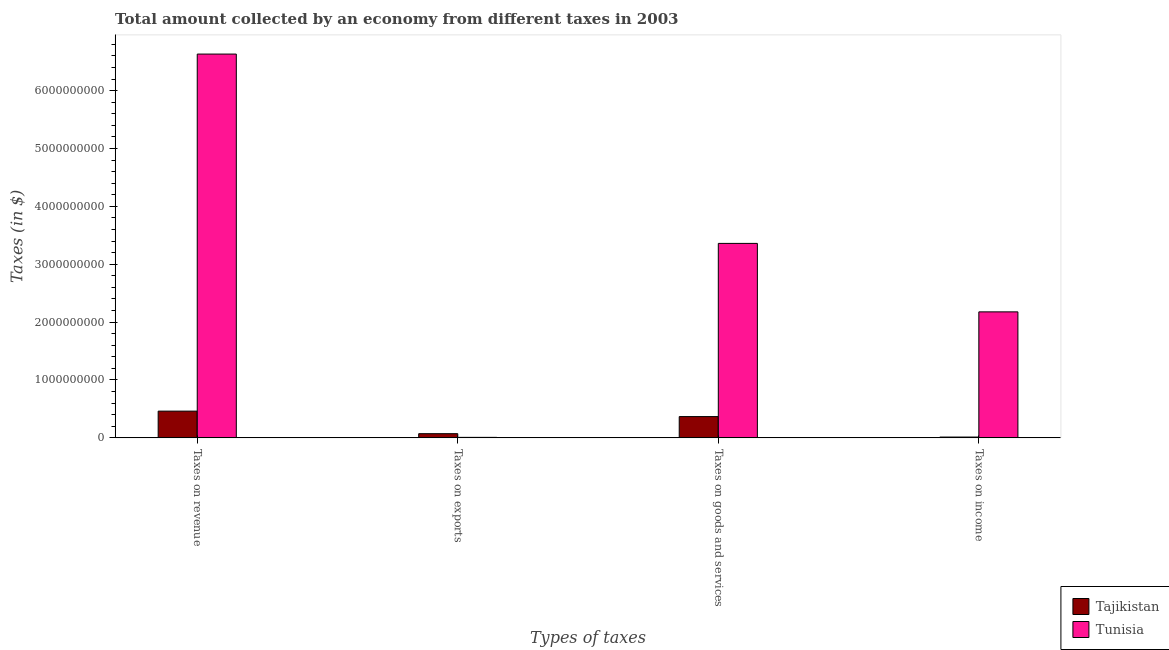How many different coloured bars are there?
Give a very brief answer. 2. Are the number of bars per tick equal to the number of legend labels?
Your response must be concise. Yes. Are the number of bars on each tick of the X-axis equal?
Your answer should be very brief. Yes. What is the label of the 4th group of bars from the left?
Your response must be concise. Taxes on income. What is the amount collected as tax on revenue in Tajikistan?
Your answer should be compact. 4.62e+08. Across all countries, what is the maximum amount collected as tax on income?
Offer a terse response. 2.18e+09. Across all countries, what is the minimum amount collected as tax on revenue?
Keep it short and to the point. 4.62e+08. In which country was the amount collected as tax on exports maximum?
Offer a very short reply. Tajikistan. In which country was the amount collected as tax on exports minimum?
Make the answer very short. Tunisia. What is the total amount collected as tax on income in the graph?
Give a very brief answer. 2.19e+09. What is the difference between the amount collected as tax on exports in Tajikistan and that in Tunisia?
Your response must be concise. 6.38e+07. What is the difference between the amount collected as tax on goods in Tajikistan and the amount collected as tax on income in Tunisia?
Offer a terse response. -1.81e+09. What is the average amount collected as tax on goods per country?
Provide a succinct answer. 1.86e+09. What is the difference between the amount collected as tax on revenue and amount collected as tax on goods in Tunisia?
Offer a terse response. 3.27e+09. In how many countries, is the amount collected as tax on exports greater than 1000000000 $?
Your response must be concise. 0. What is the ratio of the amount collected as tax on revenue in Tajikistan to that in Tunisia?
Offer a terse response. 0.07. What is the difference between the highest and the second highest amount collected as tax on income?
Provide a short and direct response. 2.16e+09. What is the difference between the highest and the lowest amount collected as tax on revenue?
Keep it short and to the point. 6.17e+09. What does the 1st bar from the left in Taxes on goods and services represents?
Offer a very short reply. Tajikistan. What does the 1st bar from the right in Taxes on exports represents?
Offer a very short reply. Tunisia. Is it the case that in every country, the sum of the amount collected as tax on revenue and amount collected as tax on exports is greater than the amount collected as tax on goods?
Ensure brevity in your answer.  Yes. Are all the bars in the graph horizontal?
Your response must be concise. No. Are the values on the major ticks of Y-axis written in scientific E-notation?
Make the answer very short. No. What is the title of the graph?
Your response must be concise. Total amount collected by an economy from different taxes in 2003. Does "Niger" appear as one of the legend labels in the graph?
Provide a succinct answer. No. What is the label or title of the X-axis?
Offer a terse response. Types of taxes. What is the label or title of the Y-axis?
Provide a short and direct response. Taxes (in $). What is the Taxes (in $) of Tajikistan in Taxes on revenue?
Make the answer very short. 4.62e+08. What is the Taxes (in $) in Tunisia in Taxes on revenue?
Your answer should be compact. 6.63e+09. What is the Taxes (in $) of Tajikistan in Taxes on exports?
Provide a short and direct response. 7.25e+07. What is the Taxes (in $) in Tunisia in Taxes on exports?
Give a very brief answer. 8.70e+06. What is the Taxes (in $) of Tajikistan in Taxes on goods and services?
Keep it short and to the point. 3.68e+08. What is the Taxes (in $) in Tunisia in Taxes on goods and services?
Keep it short and to the point. 3.36e+09. What is the Taxes (in $) of Tajikistan in Taxes on income?
Offer a very short reply. 1.42e+07. What is the Taxes (in $) in Tunisia in Taxes on income?
Offer a terse response. 2.18e+09. Across all Types of taxes, what is the maximum Taxes (in $) of Tajikistan?
Provide a succinct answer. 4.62e+08. Across all Types of taxes, what is the maximum Taxes (in $) of Tunisia?
Your answer should be very brief. 6.63e+09. Across all Types of taxes, what is the minimum Taxes (in $) in Tajikistan?
Your answer should be compact. 1.42e+07. Across all Types of taxes, what is the minimum Taxes (in $) of Tunisia?
Your response must be concise. 8.70e+06. What is the total Taxes (in $) in Tajikistan in the graph?
Make the answer very short. 9.16e+08. What is the total Taxes (in $) of Tunisia in the graph?
Provide a succinct answer. 1.22e+1. What is the difference between the Taxes (in $) of Tajikistan in Taxes on revenue and that in Taxes on exports?
Provide a short and direct response. 3.89e+08. What is the difference between the Taxes (in $) in Tunisia in Taxes on revenue and that in Taxes on exports?
Make the answer very short. 6.62e+09. What is the difference between the Taxes (in $) in Tajikistan in Taxes on revenue and that in Taxes on goods and services?
Your answer should be very brief. 9.43e+07. What is the difference between the Taxes (in $) in Tunisia in Taxes on revenue and that in Taxes on goods and services?
Your response must be concise. 3.27e+09. What is the difference between the Taxes (in $) in Tajikistan in Taxes on revenue and that in Taxes on income?
Keep it short and to the point. 4.48e+08. What is the difference between the Taxes (in $) in Tunisia in Taxes on revenue and that in Taxes on income?
Keep it short and to the point. 4.45e+09. What is the difference between the Taxes (in $) of Tajikistan in Taxes on exports and that in Taxes on goods and services?
Your answer should be very brief. -2.95e+08. What is the difference between the Taxes (in $) of Tunisia in Taxes on exports and that in Taxes on goods and services?
Your answer should be compact. -3.35e+09. What is the difference between the Taxes (in $) of Tajikistan in Taxes on exports and that in Taxes on income?
Your answer should be very brief. 5.83e+07. What is the difference between the Taxes (in $) of Tunisia in Taxes on exports and that in Taxes on income?
Make the answer very short. -2.17e+09. What is the difference between the Taxes (in $) in Tajikistan in Taxes on goods and services and that in Taxes on income?
Your answer should be very brief. 3.54e+08. What is the difference between the Taxes (in $) in Tunisia in Taxes on goods and services and that in Taxes on income?
Offer a terse response. 1.18e+09. What is the difference between the Taxes (in $) in Tajikistan in Taxes on revenue and the Taxes (in $) in Tunisia in Taxes on exports?
Make the answer very short. 4.53e+08. What is the difference between the Taxes (in $) in Tajikistan in Taxes on revenue and the Taxes (in $) in Tunisia in Taxes on goods and services?
Offer a very short reply. -2.90e+09. What is the difference between the Taxes (in $) in Tajikistan in Taxes on revenue and the Taxes (in $) in Tunisia in Taxes on income?
Your response must be concise. -1.71e+09. What is the difference between the Taxes (in $) of Tajikistan in Taxes on exports and the Taxes (in $) of Tunisia in Taxes on goods and services?
Provide a succinct answer. -3.29e+09. What is the difference between the Taxes (in $) of Tajikistan in Taxes on exports and the Taxes (in $) of Tunisia in Taxes on income?
Give a very brief answer. -2.10e+09. What is the difference between the Taxes (in $) of Tajikistan in Taxes on goods and services and the Taxes (in $) of Tunisia in Taxes on income?
Offer a very short reply. -1.81e+09. What is the average Taxes (in $) in Tajikistan per Types of taxes?
Provide a short and direct response. 2.29e+08. What is the average Taxes (in $) of Tunisia per Types of taxes?
Offer a very short reply. 3.04e+09. What is the difference between the Taxes (in $) of Tajikistan and Taxes (in $) of Tunisia in Taxes on revenue?
Your response must be concise. -6.17e+09. What is the difference between the Taxes (in $) in Tajikistan and Taxes (in $) in Tunisia in Taxes on exports?
Provide a short and direct response. 6.38e+07. What is the difference between the Taxes (in $) of Tajikistan and Taxes (in $) of Tunisia in Taxes on goods and services?
Offer a terse response. -2.99e+09. What is the difference between the Taxes (in $) in Tajikistan and Taxes (in $) in Tunisia in Taxes on income?
Provide a short and direct response. -2.16e+09. What is the ratio of the Taxes (in $) of Tajikistan in Taxes on revenue to that in Taxes on exports?
Ensure brevity in your answer.  6.37. What is the ratio of the Taxes (in $) of Tunisia in Taxes on revenue to that in Taxes on exports?
Ensure brevity in your answer.  762.16. What is the ratio of the Taxes (in $) of Tajikistan in Taxes on revenue to that in Taxes on goods and services?
Give a very brief answer. 1.26. What is the ratio of the Taxes (in $) in Tunisia in Taxes on revenue to that in Taxes on goods and services?
Your response must be concise. 1.97. What is the ratio of the Taxes (in $) of Tajikistan in Taxes on revenue to that in Taxes on income?
Offer a very short reply. 32.62. What is the ratio of the Taxes (in $) in Tunisia in Taxes on revenue to that in Taxes on income?
Offer a very short reply. 3.05. What is the ratio of the Taxes (in $) of Tajikistan in Taxes on exports to that in Taxes on goods and services?
Your answer should be very brief. 0.2. What is the ratio of the Taxes (in $) in Tunisia in Taxes on exports to that in Taxes on goods and services?
Ensure brevity in your answer.  0. What is the ratio of the Taxes (in $) in Tajikistan in Taxes on exports to that in Taxes on income?
Make the answer very short. 5.12. What is the ratio of the Taxes (in $) of Tunisia in Taxes on exports to that in Taxes on income?
Keep it short and to the point. 0. What is the ratio of the Taxes (in $) of Tajikistan in Taxes on goods and services to that in Taxes on income?
Ensure brevity in your answer.  25.96. What is the ratio of the Taxes (in $) in Tunisia in Taxes on goods and services to that in Taxes on income?
Your answer should be compact. 1.54. What is the difference between the highest and the second highest Taxes (in $) in Tajikistan?
Your answer should be compact. 9.43e+07. What is the difference between the highest and the second highest Taxes (in $) of Tunisia?
Offer a very short reply. 3.27e+09. What is the difference between the highest and the lowest Taxes (in $) of Tajikistan?
Ensure brevity in your answer.  4.48e+08. What is the difference between the highest and the lowest Taxes (in $) of Tunisia?
Offer a very short reply. 6.62e+09. 